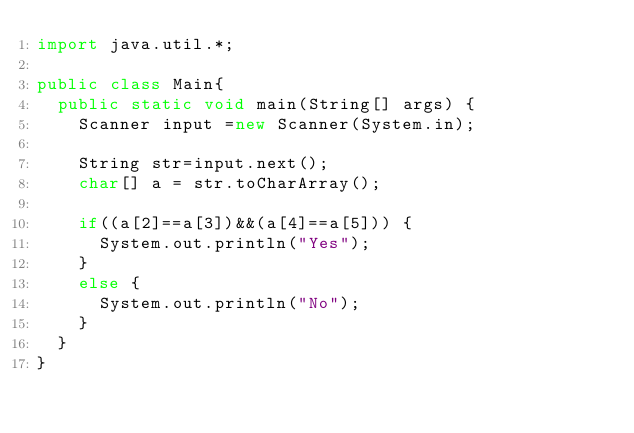<code> <loc_0><loc_0><loc_500><loc_500><_Java_>import java.util.*;

public class Main{
	public static void main(String[] args) {
		Scanner input =new Scanner(System.in);
		
		String str=input.next();
		char[] a = str.toCharArray();
		
		if((a[2]==a[3])&&(a[4]==a[5])) {
			System.out.println("Yes");
		}
		else {
			System.out.println("No");
		}
	}	
}
</code> 